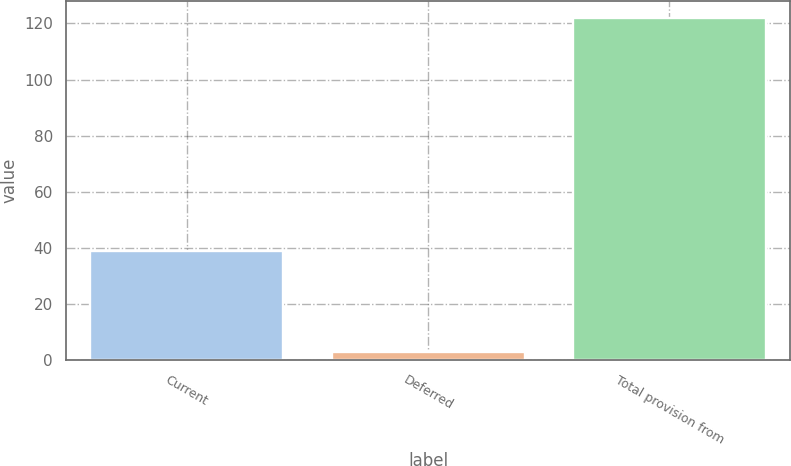Convert chart. <chart><loc_0><loc_0><loc_500><loc_500><bar_chart><fcel>Current<fcel>Deferred<fcel>Total provision from<nl><fcel>39<fcel>3<fcel>122<nl></chart> 